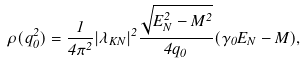Convert formula to latex. <formula><loc_0><loc_0><loc_500><loc_500>\rho ( q _ { 0 } ^ { 2 } ) = \frac { 1 } { 4 \pi ^ { 2 } } | \lambda _ { K N } | ^ { 2 } \frac { \sqrt { E _ { N } ^ { 2 } - M ^ { 2 } } } { 4 q _ { 0 } } ( \gamma _ { 0 } E _ { N } - M ) ,</formula> 